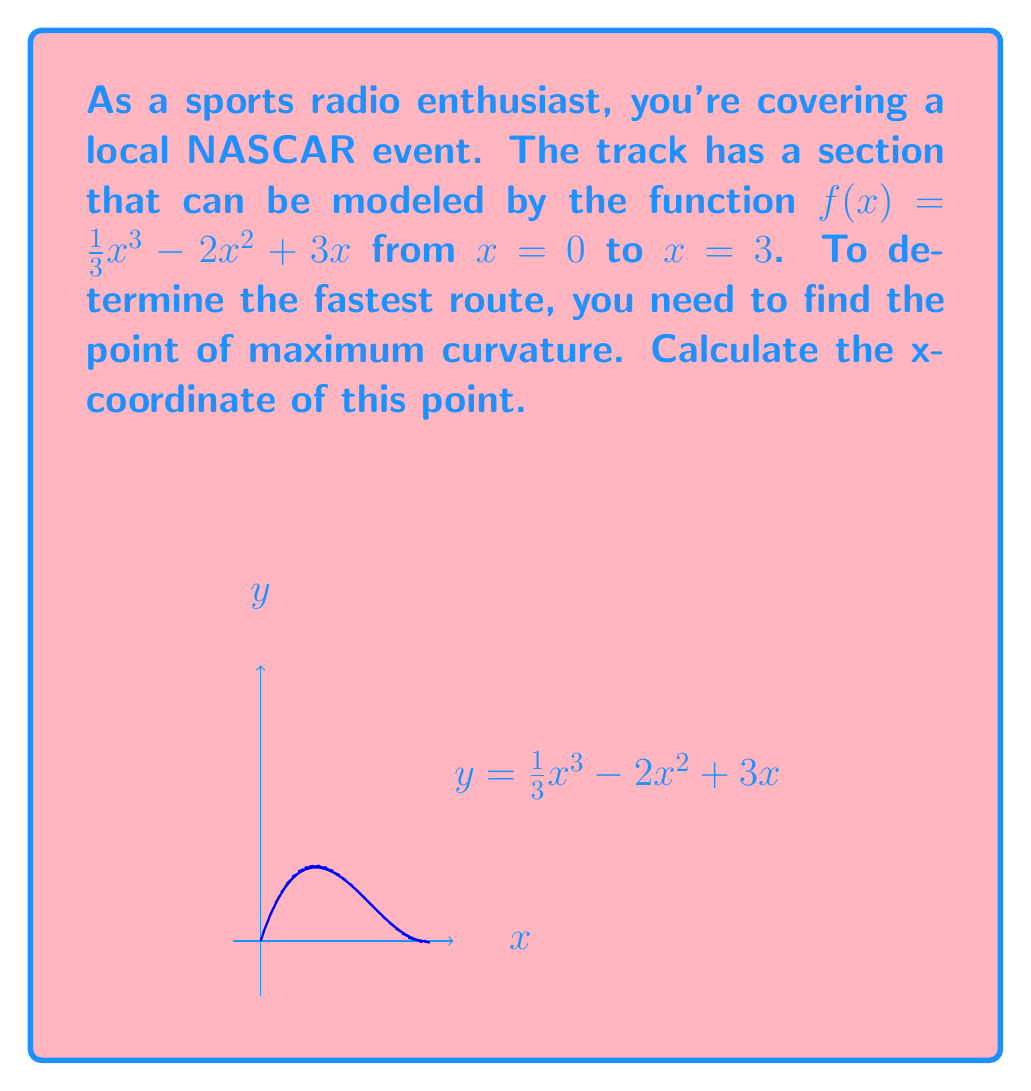Teach me how to tackle this problem. To find the point of maximum curvature, we need to follow these steps:

1) The curvature formula for a function $y = f(x)$ is:

   $$\kappa = \frac{|f''(x)|}{(1 + [f'(x)]^2)^{3/2}}$$

2) First, let's find $f'(x)$ and $f''(x)$:
   
   $f'(x) = x^2 - 4x + 3$
   $f''(x) = 2x - 4$

3) Now, we substitute these into the curvature formula:

   $$\kappa = \frac{|2x - 4|}{(1 + (x^2 - 4x + 3)^2)^{3/2}}$$

4) To find the maximum curvature, we need to differentiate $\kappa$ with respect to $x$ and set it to zero. However, this leads to a complex equation.

5) Instead, we can observe that the numerator $|2x - 4|$ reaches its minimum at $x = 2$, and the denominator is always positive.

6) Therefore, the curvature will be maximum when $x = 2$, as this is where the numerator transitions from decreasing to increasing.

7) We can confirm this by plotting the curvature function or checking values on either side of $x = 2$.
Answer: $x = 2$ 